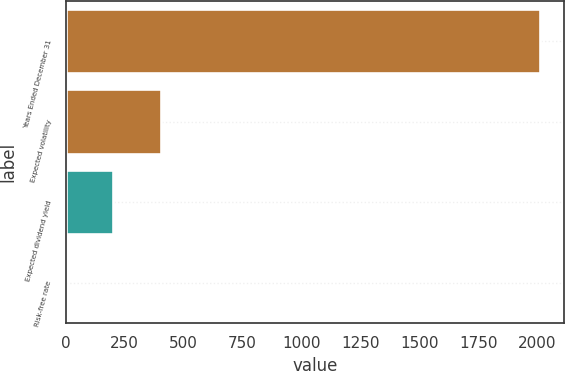<chart> <loc_0><loc_0><loc_500><loc_500><bar_chart><fcel>Years Ended December 31<fcel>Expected volatility<fcel>Expected dividend yield<fcel>Risk-free rate<nl><fcel>2014<fcel>403.44<fcel>202.12<fcel>0.8<nl></chart> 